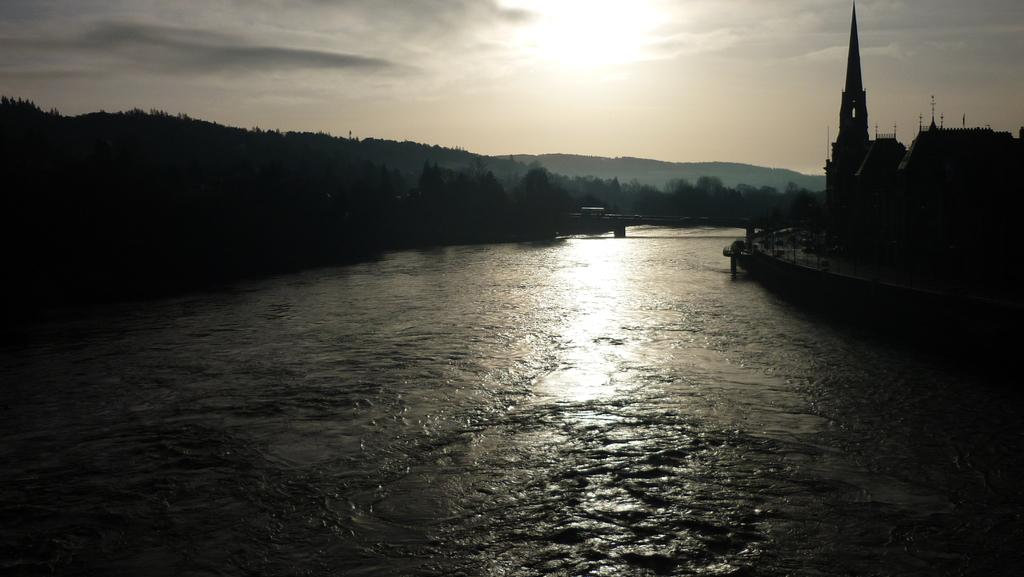What is located in the middle of the image? There is water in the middle of the image. What type of structures can be seen on the right side of the image? There are buildings on the right side of the image. What type of vegetation is on the left side of the image? There are trees on the left side of the image. What is visible at the top of the image? The sky is visible at the top of the image. Can you tell me how many rails are visible in the image? There are no rails present in the image. Is the mother in the image holding a child? A: There is no mother or child present in the image. 